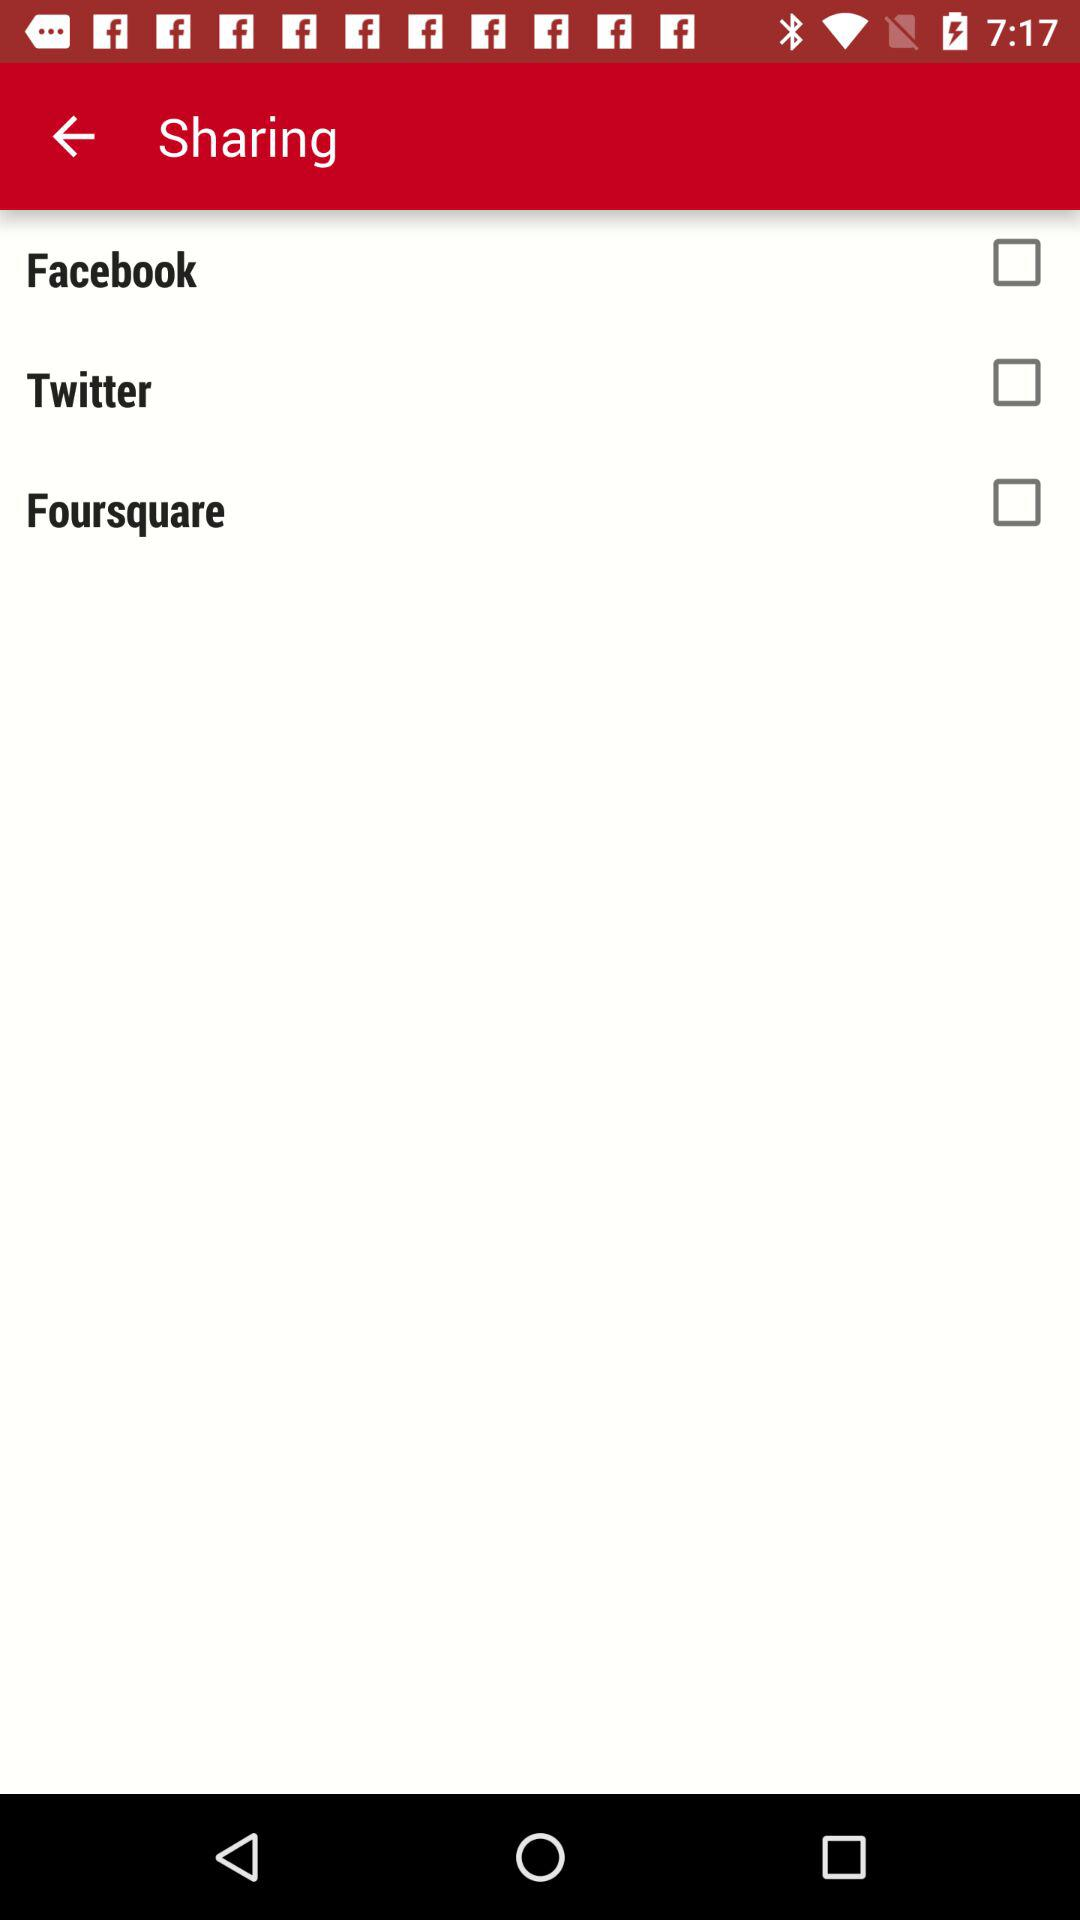What is the current status of "Twitter"? The current status is "off". 